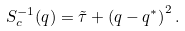<formula> <loc_0><loc_0><loc_500><loc_500>S _ { c } ^ { - 1 } ( q ) = \tilde { \tau } + \left ( q - q ^ { \ast } \right ) ^ { 2 } .</formula> 